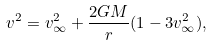<formula> <loc_0><loc_0><loc_500><loc_500>v ^ { 2 } = v ^ { 2 } _ { \infty } + \frac { 2 G M } { r } ( 1 - 3 v ^ { 2 } _ { \infty } ) ,</formula> 